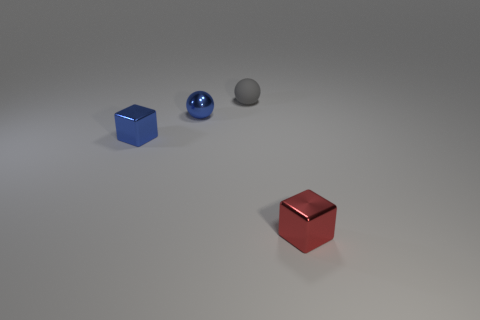Add 1 tiny metallic cubes. How many objects exist? 5 Subtract 1 blue balls. How many objects are left? 3 Subtract all small cyan rubber cubes. Subtract all red metal things. How many objects are left? 3 Add 1 gray matte things. How many gray matte things are left? 2 Add 2 tiny rubber objects. How many tiny rubber objects exist? 3 